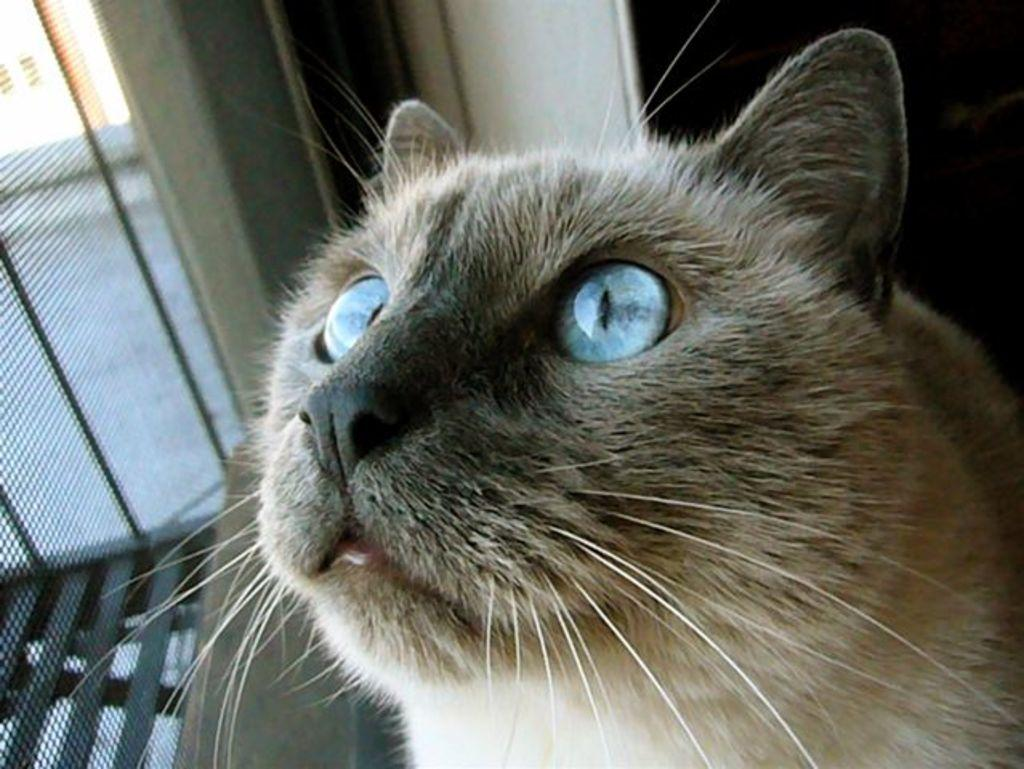What type of animal is in the image? There is a cat in the image. Can you describe the coloring of the cat? The cat has cream and black coloring. What can be seen in the background of the image? There is a wall and a net window in the background of the image. What type of disgust can be seen on the cat's face in the image? There is no indication of disgust on the cat's face in the image. What substance is the cat using to climb the wall in the image? The cat is not climbing the wall in the image, and there is no substance involved in its position. 